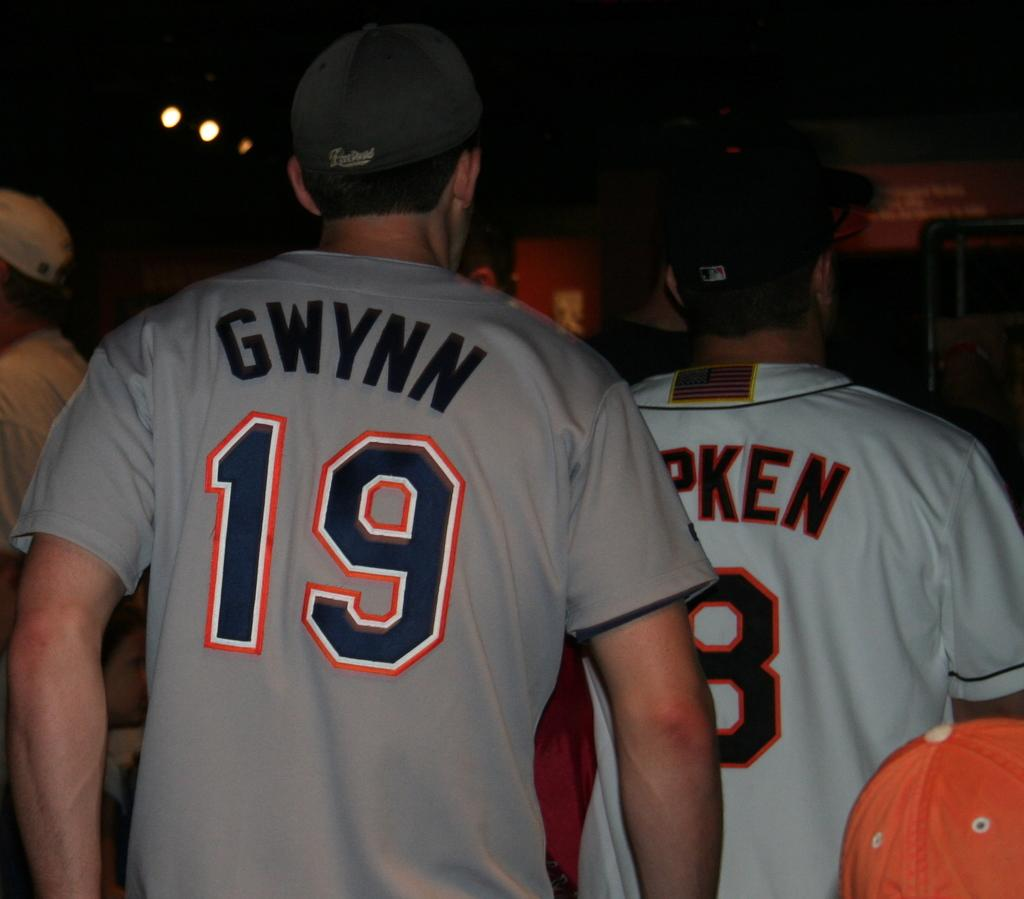Provide a one-sentence caption for the provided image. The back of fans wearing GWYNN 19 shirt and baseball caps exit. 